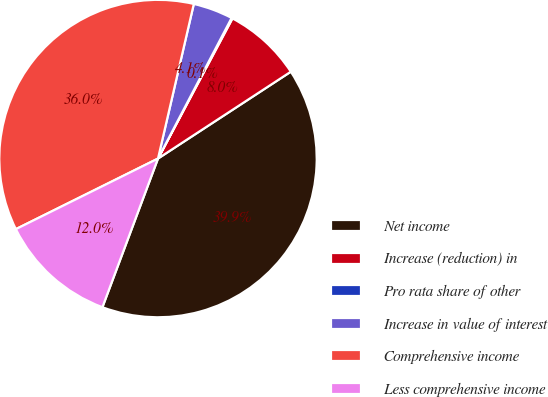Convert chart to OTSL. <chart><loc_0><loc_0><loc_500><loc_500><pie_chart><fcel>Net income<fcel>Increase (reduction) in<fcel>Pro rata share of other<fcel>Increase in value of interest<fcel>Comprehensive income<fcel>Less comprehensive income<nl><fcel>39.91%<fcel>8.01%<fcel>0.1%<fcel>4.05%<fcel>35.96%<fcel>11.97%<nl></chart> 